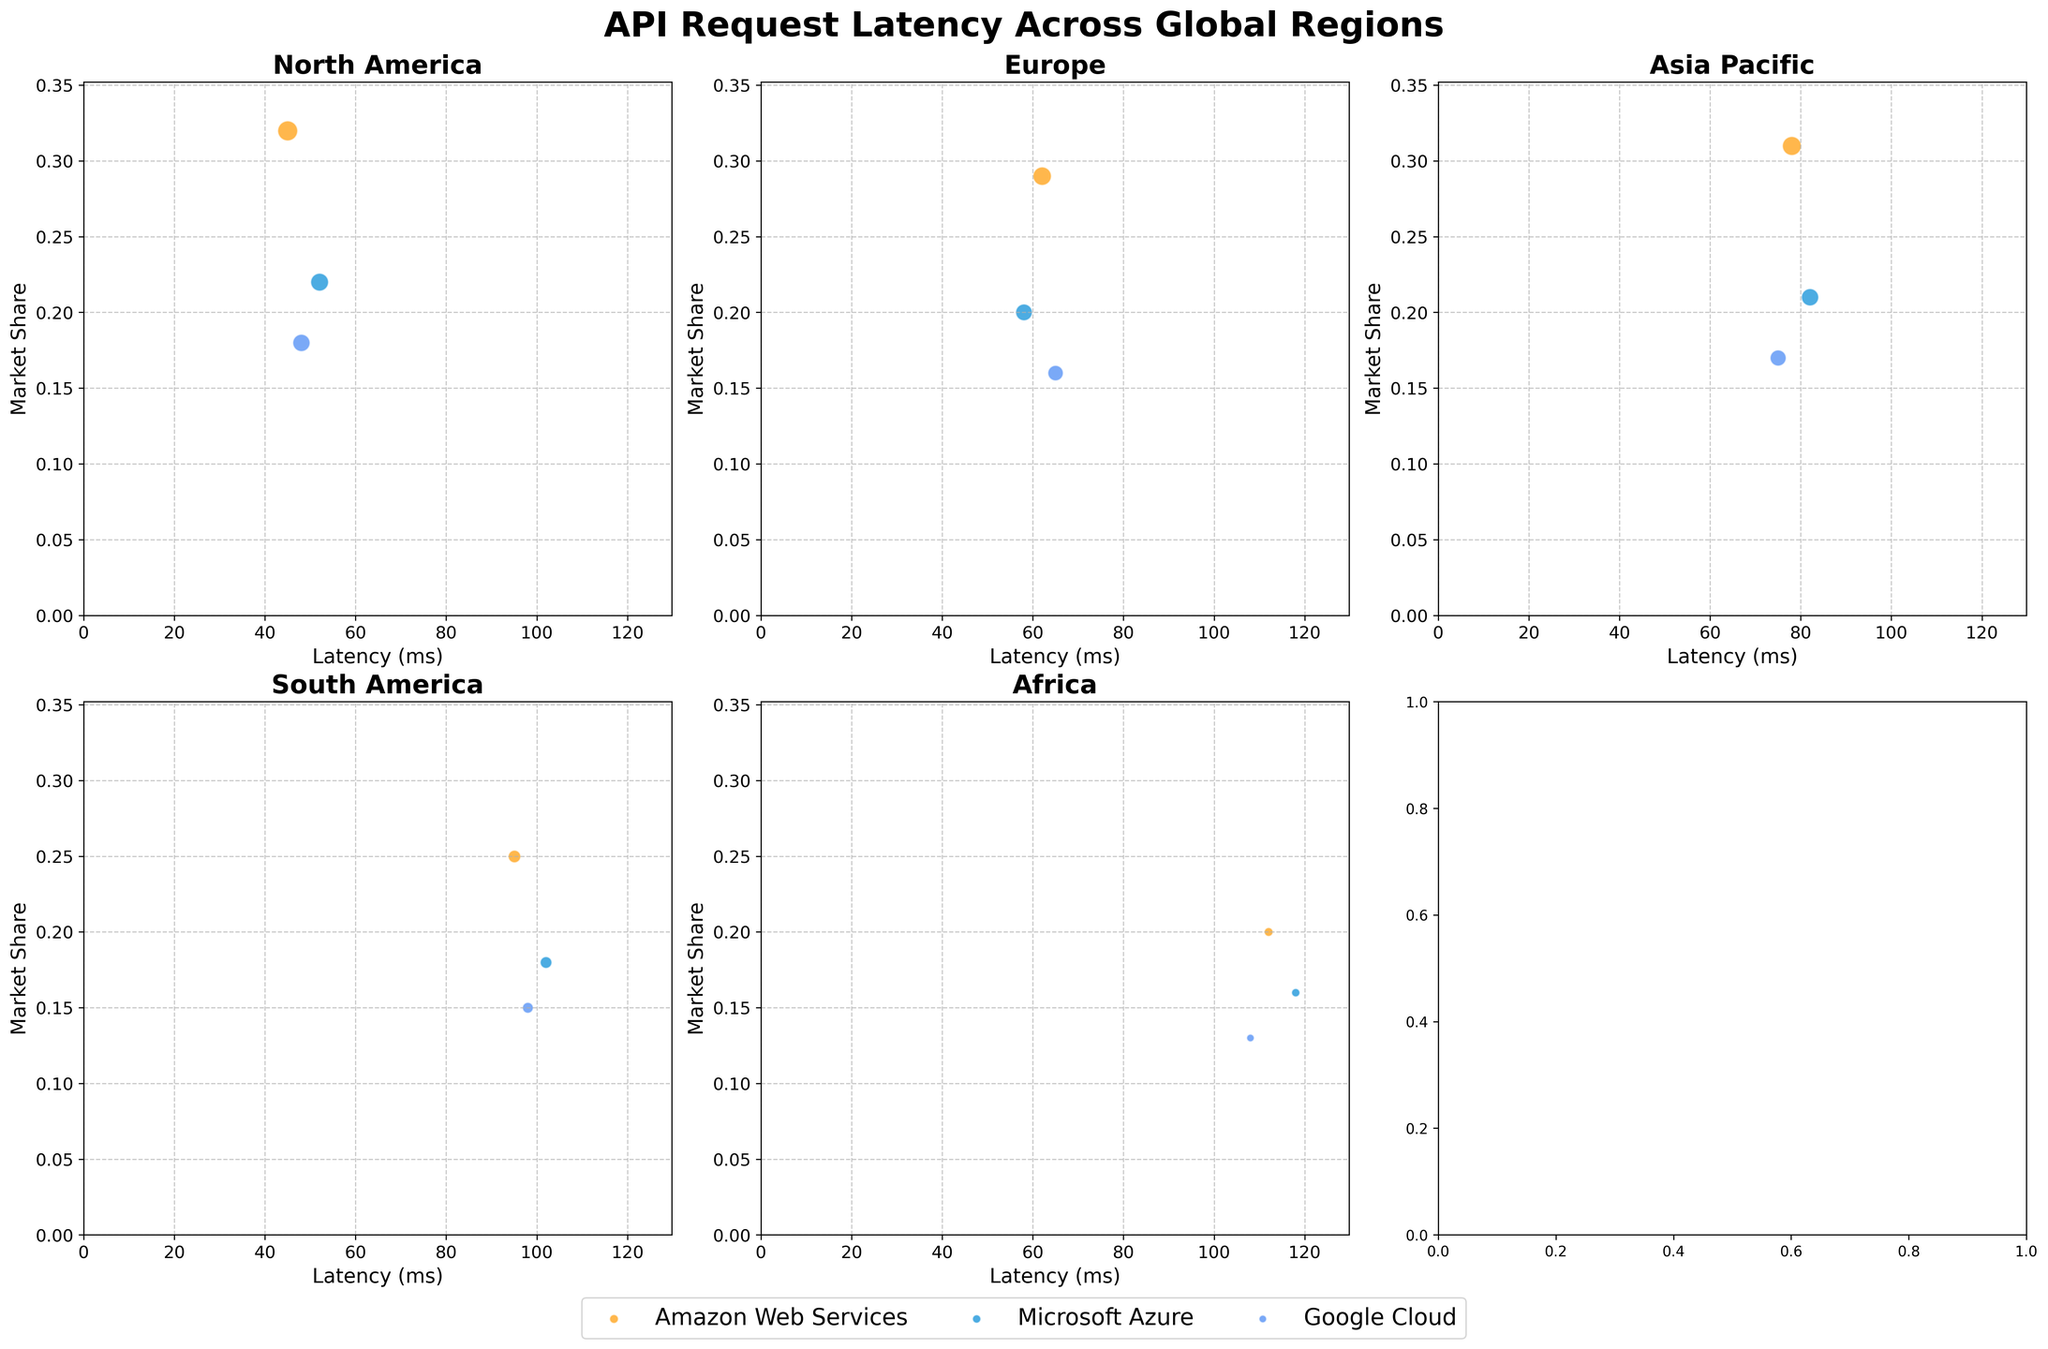What is the title of the plotted figure? The title of the plotted figure is located at the top of the subplot and is typically in a larger and bolder font compared to other text elements.
Answer: API Request Latency Across Global Regions Which region shows the highest latency for Google Cloud? By observing the Y-axis and the data points for Google Cloud across regions, compare the latency values. The highest latency is identified by the data point that appears furthest to the right.
Answer: Africa Which platform has the largest market share in North America? In the subplot for North America, compare the market share values on the Y-axis for each platform. The platform with the highest value represents the largest market share.
Answer: Amazon Web Services How does the latency for Microsoft Azure in South America compare to its latency in Europe? Locate the subplots for South America and Europe, then find the latency values for Microsoft Azure in both regions. Compare these values directly.
Answer: Higher in South America What is the relationship between request volume and bubble size? Observe how the size of the bubbles changes with respect to the request volume data. The bubble size should increase with higher request volumes.
Answer: Larger bubbles correspond to higher request volumes Compare the market share and latency of Amazon Web Services in North America and Europe. Identify the data points for Amazon Web Services in both North America and Europe subplots. Compare the values for market share and latency by looking at their respective positions on the X and Y axes.
Answer: Higher market share and lower latency in North America Which region has the smallest bubble for Google Cloud? Look at the specific subplot representing each region and identify the size of the bubbles for Google Cloud. The smallest bubble indicates the smallest request volume.
Answer: Africa What trend can you observe about latency and market share across regions for AWS? Examine the pattern of the data points for Amazon Web Services across different regions in terms of latency and market share. Notice any consistent behavior or trends.
Answer: As latency increases, market share tends to decrease Is there a region where all platforms have similar latencies? Compare the spread of latency values within each region's subplot across all platforms. Identify if any region displays close latency values for all platforms.
Answer: North America How does the market share of Microsoft Azure compare in Africa versus the Asia Pacific? Locate the subplots for Africa and Asia Pacific, and compare the market share values on the Y-axis for Microsoft Azure in both regions.
Answer: Higher in the Asia Pacific 